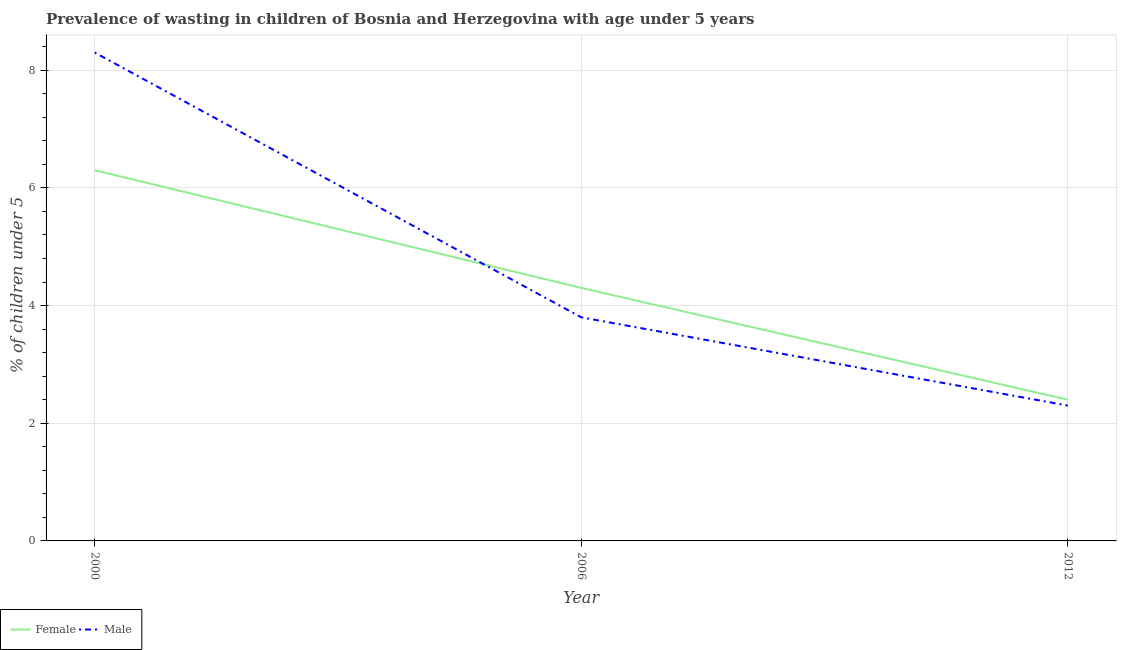What is the percentage of undernourished male children in 2000?
Offer a very short reply. 8.3. Across all years, what is the maximum percentage of undernourished male children?
Your response must be concise. 8.3. Across all years, what is the minimum percentage of undernourished female children?
Ensure brevity in your answer.  2.4. In which year was the percentage of undernourished female children minimum?
Give a very brief answer. 2012. What is the total percentage of undernourished male children in the graph?
Offer a terse response. 14.4. What is the difference between the percentage of undernourished female children in 2000 and that in 2012?
Your answer should be compact. 3.9. What is the difference between the percentage of undernourished male children in 2006 and the percentage of undernourished female children in 2000?
Provide a succinct answer. -2.5. What is the average percentage of undernourished female children per year?
Your response must be concise. 4.33. In the year 2012, what is the difference between the percentage of undernourished female children and percentage of undernourished male children?
Keep it short and to the point. 0.1. What is the ratio of the percentage of undernourished female children in 2000 to that in 2006?
Provide a short and direct response. 1.47. Is the percentage of undernourished female children in 2006 less than that in 2012?
Provide a succinct answer. No. What is the difference between the highest and the second highest percentage of undernourished male children?
Your response must be concise. 4.5. What is the difference between the highest and the lowest percentage of undernourished male children?
Provide a succinct answer. 6. Is the percentage of undernourished female children strictly greater than the percentage of undernourished male children over the years?
Provide a succinct answer. No. How many years are there in the graph?
Give a very brief answer. 3. Are the values on the major ticks of Y-axis written in scientific E-notation?
Keep it short and to the point. No. Does the graph contain grids?
Ensure brevity in your answer.  Yes. How many legend labels are there?
Provide a succinct answer. 2. How are the legend labels stacked?
Provide a short and direct response. Horizontal. What is the title of the graph?
Your answer should be very brief. Prevalence of wasting in children of Bosnia and Herzegovina with age under 5 years. Does "Non-pregnant women" appear as one of the legend labels in the graph?
Provide a succinct answer. No. What is the label or title of the X-axis?
Provide a short and direct response. Year. What is the label or title of the Y-axis?
Give a very brief answer.  % of children under 5. What is the  % of children under 5 of Female in 2000?
Make the answer very short. 6.3. What is the  % of children under 5 in Male in 2000?
Provide a succinct answer. 8.3. What is the  % of children under 5 of Female in 2006?
Provide a short and direct response. 4.3. What is the  % of children under 5 of Male in 2006?
Make the answer very short. 3.8. What is the  % of children under 5 of Female in 2012?
Give a very brief answer. 2.4. What is the  % of children under 5 of Male in 2012?
Your answer should be compact. 2.3. Across all years, what is the maximum  % of children under 5 of Female?
Keep it short and to the point. 6.3. Across all years, what is the maximum  % of children under 5 of Male?
Make the answer very short. 8.3. Across all years, what is the minimum  % of children under 5 in Female?
Give a very brief answer. 2.4. Across all years, what is the minimum  % of children under 5 of Male?
Your answer should be very brief. 2.3. What is the total  % of children under 5 in Male in the graph?
Your answer should be compact. 14.4. What is the difference between the  % of children under 5 in Male in 2000 and that in 2012?
Make the answer very short. 6. What is the difference between the  % of children under 5 of Female in 2006 and that in 2012?
Keep it short and to the point. 1.9. What is the difference between the  % of children under 5 of Female in 2000 and the  % of children under 5 of Male in 2012?
Your response must be concise. 4. What is the average  % of children under 5 in Female per year?
Your answer should be very brief. 4.33. What is the average  % of children under 5 of Male per year?
Your response must be concise. 4.8. In the year 2006, what is the difference between the  % of children under 5 in Female and  % of children under 5 in Male?
Keep it short and to the point. 0.5. What is the ratio of the  % of children under 5 of Female in 2000 to that in 2006?
Offer a terse response. 1.47. What is the ratio of the  % of children under 5 in Male in 2000 to that in 2006?
Keep it short and to the point. 2.18. What is the ratio of the  % of children under 5 in Female in 2000 to that in 2012?
Offer a very short reply. 2.62. What is the ratio of the  % of children under 5 in Male in 2000 to that in 2012?
Provide a succinct answer. 3.61. What is the ratio of the  % of children under 5 in Female in 2006 to that in 2012?
Give a very brief answer. 1.79. What is the ratio of the  % of children under 5 in Male in 2006 to that in 2012?
Keep it short and to the point. 1.65. What is the difference between the highest and the second highest  % of children under 5 of Male?
Your answer should be very brief. 4.5. 